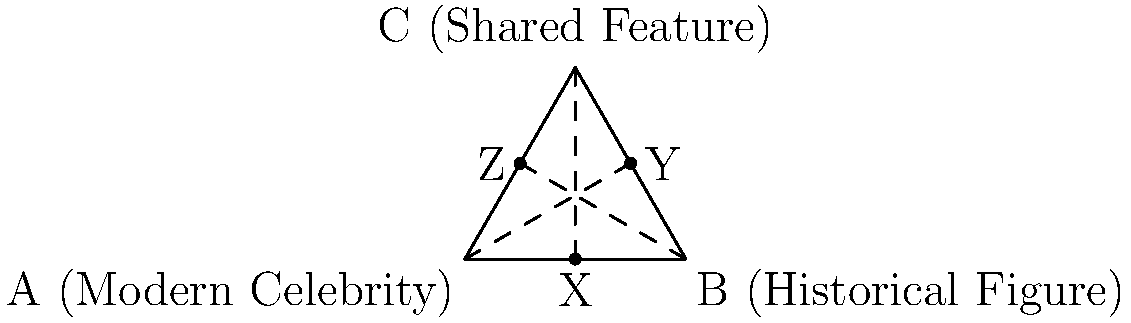In this humorous celebrity-historical figure face-off, we've identified congruent facial features between a modern star and a historical icon. If triangle ABC represents this comparison, with A being the modern celebrity, B the historical figure, and C their shared feature, what geometric concept do the dashed lines illustrate? How might this relate to the witty observation that some facial features never go out of style? Let's break this down with a dash of historical humor:

1. Triangle ABC represents our celebrity face-off, with modern and historical figures at the base.

2. The dashed lines drawn from each vertex to the midpoint of the opposite side are called medians.

3. In geometry, medians have a special property: they always intersect at a point called the centroid, which divides each median in a 2:1 ratio.

4. This centroid is often referred to as the "center of gravity" of the triangle.

5. In our celebrity comparison:
   - The medians represent the blending of features across time.
   - The centroid symbolizes the timeless nature of certain facial characteristics.

6. Just as the centroid balances the triangle, these shared features create a "balance" between modern and historical beauty standards.

7. The congruence of these features, represented by the equal parts of the triangle, suggests that some aspects of attractiveness are indeed timeless.

8. Humorously, we could say that Mother Nature found her "sweet spot" for certain facial features and decided to stick with the winning formula across centuries!

This geometric representation wittily illustrates how some facial features have remained "en vogue" from historical times to the modern day, proving that good looks, like a well-constructed triangle, stand the test of time.
Answer: Medians and centroid 